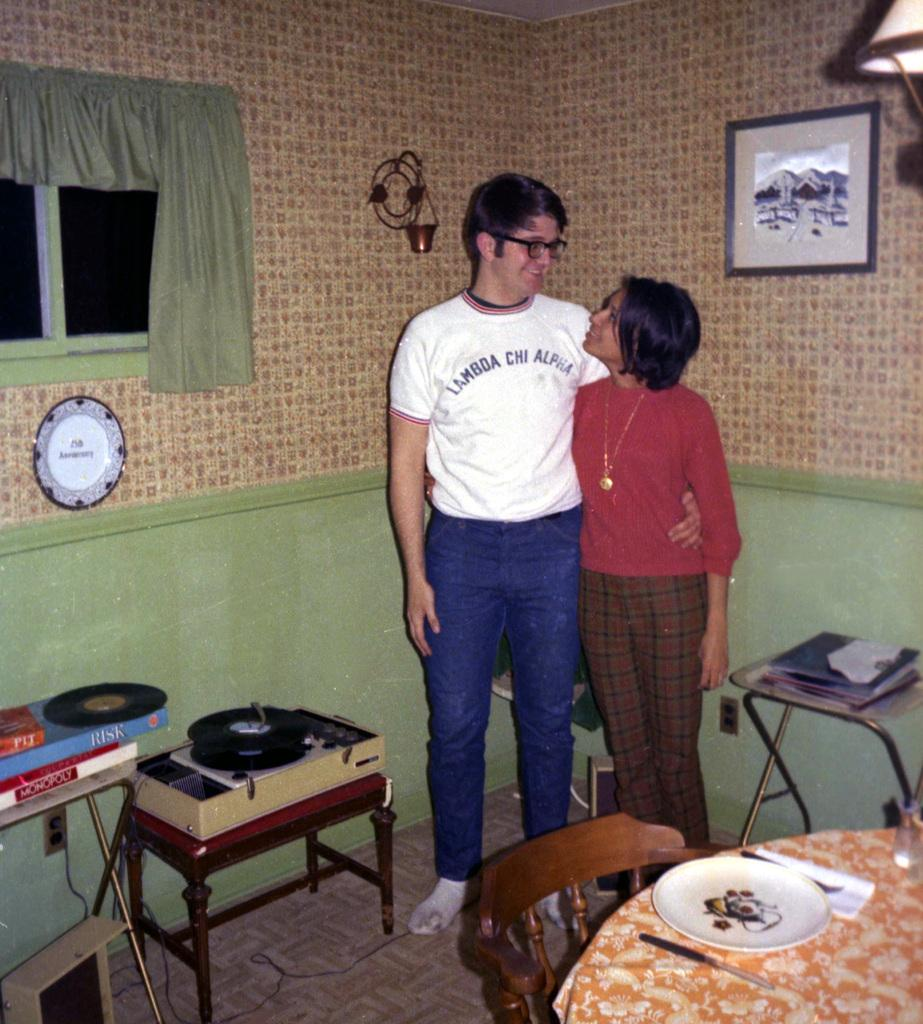<image>
Offer a succinct explanation of the picture presented. a man wearing a shirt that says 'lambda chi alpha' on it 